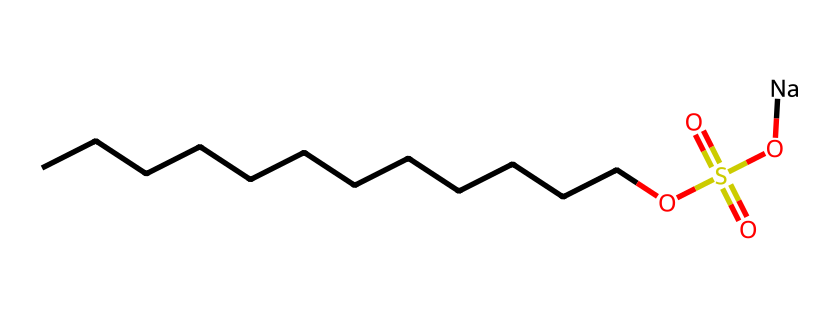How many carbon atoms are present in this surfactant? The SMILES representation shows a straight-chain alkane with 'CCCCCCCCCCCC' indicating a total of 12 carbon atoms.
Answer: twelve What functional group is present in the chemical structure? The presence of 'OS(=O)(=O)O' indicates that it contains a sulfonic acid functional group, specifically indicated by the sulfur and the attached oxygen atoms.
Answer: sulfonic acid How many oxygen atoms are in the molecule? The SMILES indicates there are four oxygen atoms: one within the sulfonic group and three in the 'OS(=O)(=O)O' part, including the one in the sulfate and one to indicate the sulfonate's presence.
Answer: four What is the charge of the sodium ion in this surfactant? The '[Na]' indicates that there is a sodium ion which has a +1 charge as it is in its ionized form in solutions, typical for salts formed from the sulfonic acid.
Answer: plus one What type of surfactant does this structure represent? Due to the presence of a long hydrophobic carbon chain and a hydrophilic sulfonic acid group, this is a type of anionic surfactant, characterized by a negatively charged head when dissolved in water.
Answer: anionic Does this surfactant have a hydrophilic or hydrophobic character? The sulfonic acid group imparts hydrophilic properties, while the long carbon chain provides hydrophobic characteristics, making it an amphiphilic compound overall.
Answer: amphiphilic What is the role of the sodium ion in this surfactant? The sodium ion in the surfactant acts as a counterion to balance the charge of the sulfonate group, facilitating the surfactant's function in a liquid medium and increasing its solubility in water.
Answer: counterion 